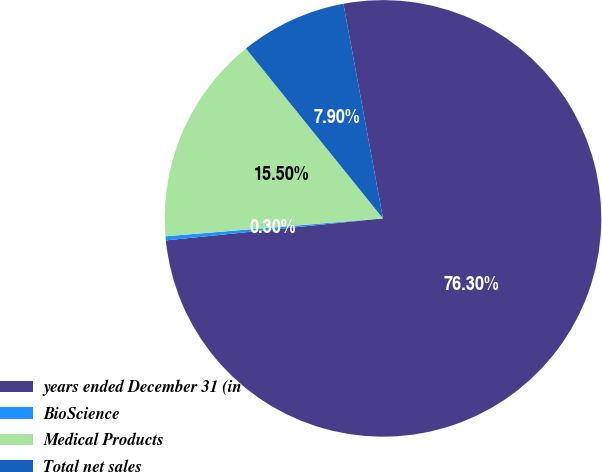Convert chart. <chart><loc_0><loc_0><loc_500><loc_500><pie_chart><fcel>years ended December 31 (in<fcel>BioScience<fcel>Medical Products<fcel>Total net sales<nl><fcel>76.29%<fcel>0.3%<fcel>15.5%<fcel>7.9%<nl></chart> 